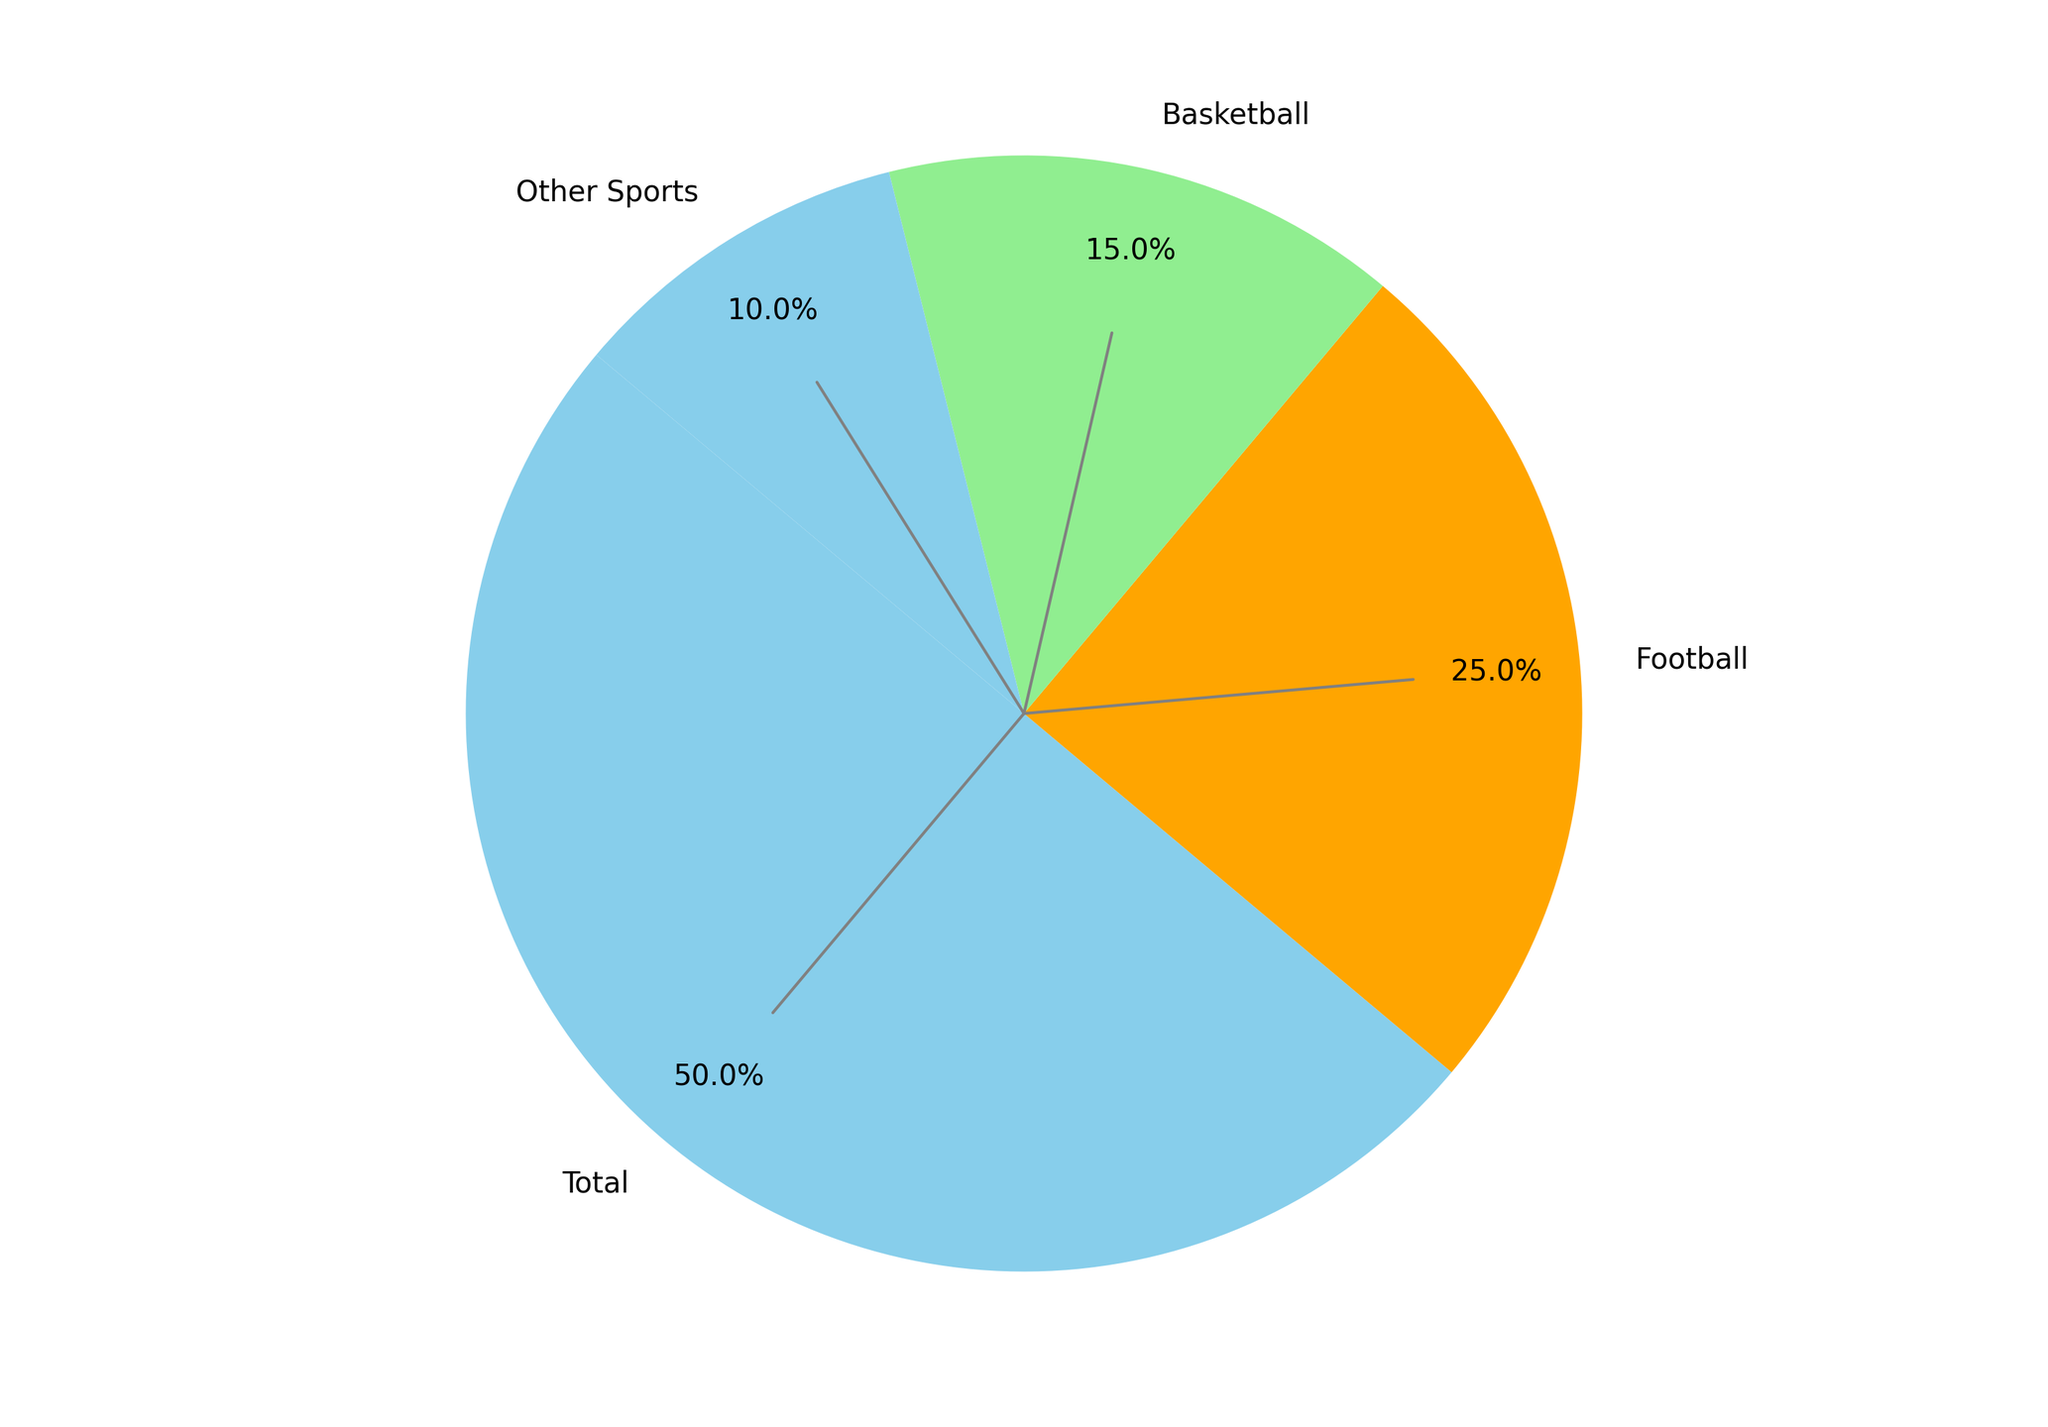What percentage of the total viewership is accounted for by football? From the main pie chart, the slice labeled 'Football' shows 50% of the total viewership.
Answer: 50% Which sport has the smallest viewership percentage in the "Other Sports" category? In the pie chart for "Other Sports", all slices for Baseball, Soccer, Lacrosse, and Track and Field are equally sized and each represents 5%. Therefore, no single sport has a smaller percentage than the others.
Answer: None Between March Madness and Regular Season in Basketball, which has a smaller slice and by how much? The pie chart shows that Regular Season has 25% and March Madness has 5%. The difference is calculated as 25% - 5% = 20%.
Answer: March Madness, 20% If you sum the viewership of Regular Season for both Football and Basketball, what is the total? Football Regular Season accounts for 40% and Basketball Regular Season accounts for 25%. Summing them up gives 40% + 25% = 65%.
Answer: 65% Is the viewership for playoffs in football greater than the viewership for March Madness in basketball? Football Playoffs are shown to have 10% viewership, whereas Basketball's March Madness has 5%. Since 10% is greater than 5%, the answer is yes.
Answer: Yes Which category, football regular season or the entirety of other sports combined, has a larger viewership percentage, and by how much? Football Regular Season has 40%, while the total for Other Sports is 20% (sum of Baseball 5%, Soccer 5%, Lacrosse 5%, and Track and Field 5%). Thus, Football Regular Season is larger by 40% - 20% = 20%.
Answer: Football Regular Season, 20% What is the cumulative percentage viewership for Baseball and Soccer? Both Baseball and Soccer represent 5% each in the "Other Sports" category. Adding them together gives 5% + 5% = 10%.
Answer: 10% Which has a larger viewership: Basketball Regular Season or Football Playoffs plus March Madness combined? Basketball Regular Season is 25%, while Football Playoffs is 10% and March Madness is 5%. Their combined viewership is 10% + 5% = 15%. Comparing 25% and 15%, Basketball Regular Season is larger.
Answer: Basketball Regular Season How does the percentage viewership of total basketball compare to total football? Basketball totals to 30% (25% Regular Season + 5% March Madness), while Football has a total of 50% (40% Regular Season + 10% Playoffs). Therefore, Football has more viewership.
Answer: Football 